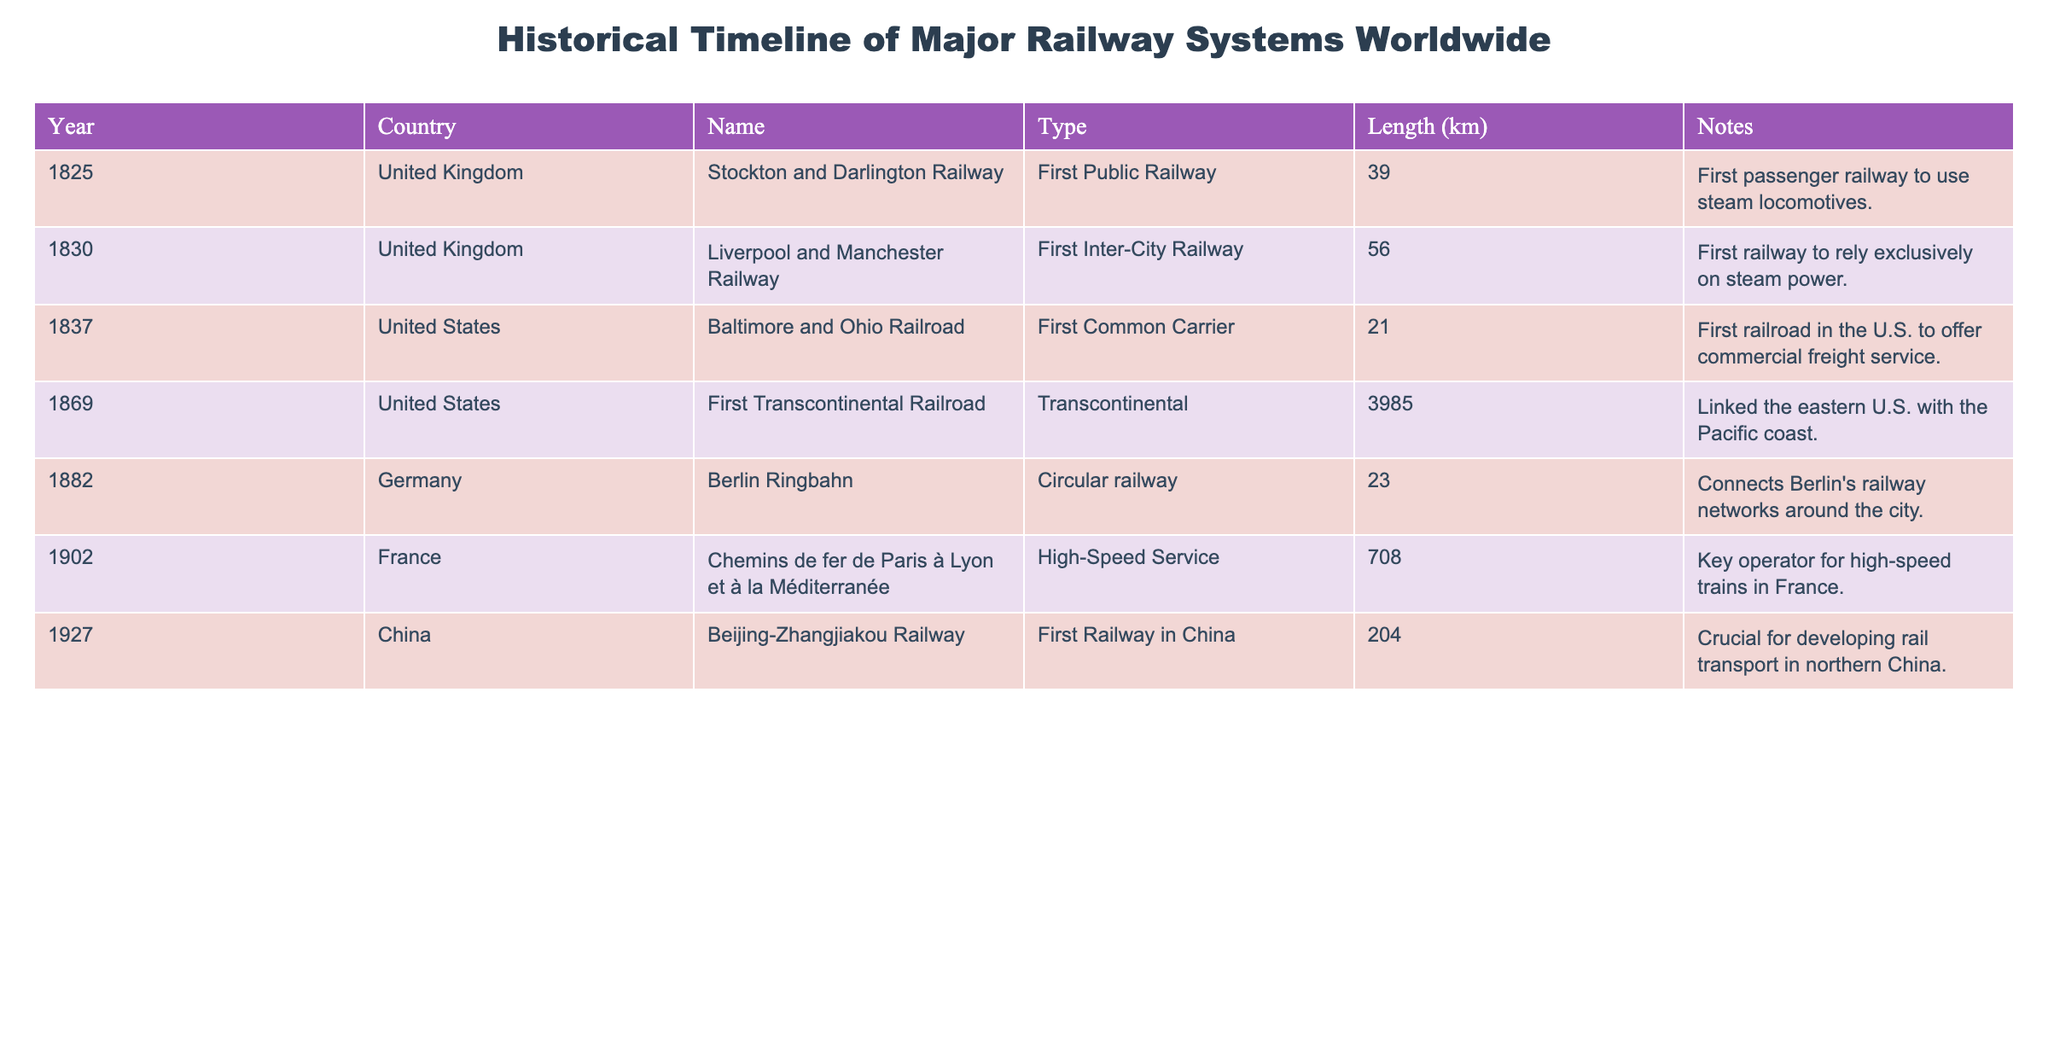What year was the first transcontinental railroad completed? The table lists the "First Transcontinental Railroad" under the year 1869. By locating the corresponding row in the table, we can directly identify the year.
Answer: 1869 Which railway in China was pivotal for developing rail transport? Referring to the table, the "Beijing-Zhangjiakou Railway" in the year 1927 is noted as the "First Railway in China" and essential for rail development in northern China.
Answer: Beijing-Zhangjiakou Railway How many kilometers was the distance of the Liverpool and Manchester Railway? By checking the table for the "Liverpool and Manchester Railway," it states that the railway length was recorded as 56 km.
Answer: 56 km What is the average length of the railways listed in the table? To find the average, we calculate the sum of all lengths: (39 + 56 + 21 + 3985 + 23 + 708 + 204) = 5086 km. Next, we divide by the number of railways (7) to find the average: 5086 / 7 ≈ 726.57 km.
Answer: 726.57 km Is the Berlin Ringbahn the first public railway? The table clearly states that the "Berlin Ringbahn" was established in 1882 but labels it as a "Circular railway," not the first public railway, which is the "Stockton and Darlington Railway." Therefore, this statement is false.
Answer: No Which country had the first railway to offer commercial freight service? According to the table, the "Baltimore and Ohio Railroad" was the first common carrier established in the United States in 1837 with a focus on commercial freight service.
Answer: United States Which railway system is the longest according to the table? From the data provided, the "First Transcontinental Railroad" has the longest length of 3985 km. No other railway in the table exceeds this distance.
Answer: First Transcontinental Railroad Is the Chemins de fer de Paris à Lyon et à la Méditerranée associated with high-speed service? Yes, the table explicitly states that "Chemins de fer de Paris à Lyon et à la Méditerranée" is associated with high-speed service in the year 1902.
Answer: Yes What types of railways are mentioned in the table? Review of the table shows various types: "First Public Railway," "First Inter-City Railway," "First Common Carrier," "Transcontinental," and others. Thus, there are multiple distinct types that represent various railway categories throughout history.
Answer: Multiple types 